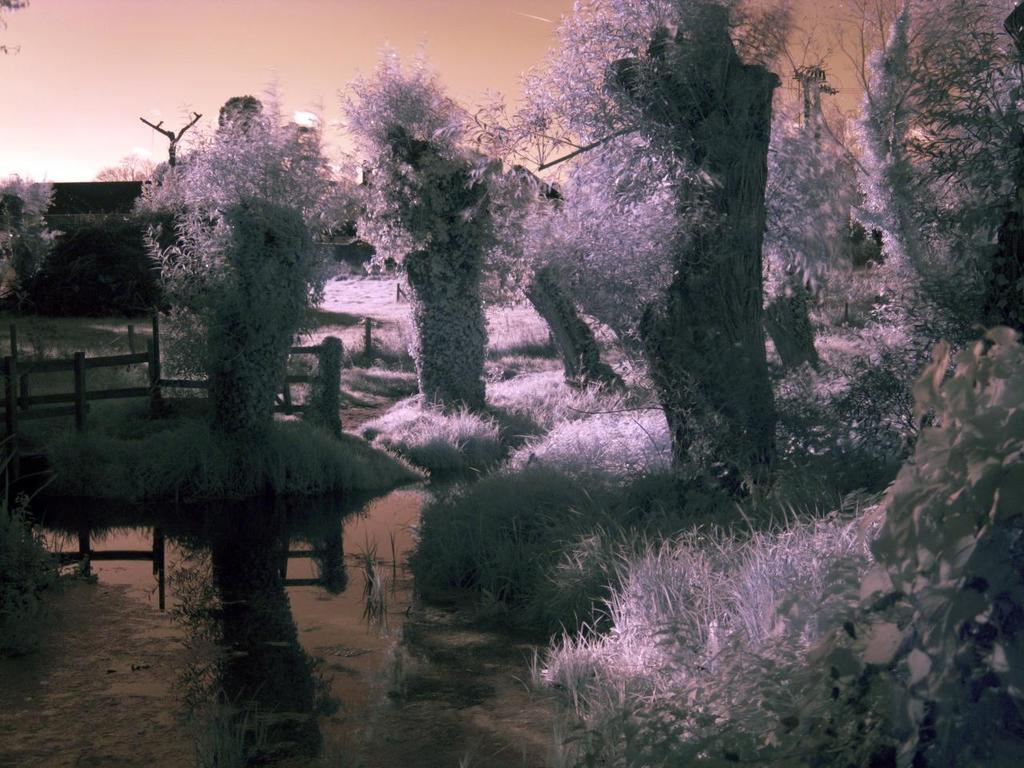What natural element can be seen in the image? Water is visible in the image. What type of vegetation is present in the image? There is grass in the image. What type of man-made structure is in the image? There is a fence in the image. What type of tall plants are in the image? There are trees in the image. What part of the natural environment is visible in the background of the image? The sky is visible in the background of the image. What type of chin can be seen on the structure in the image? There is no chin present in the image, as it features natural elements and a man-made structure. 